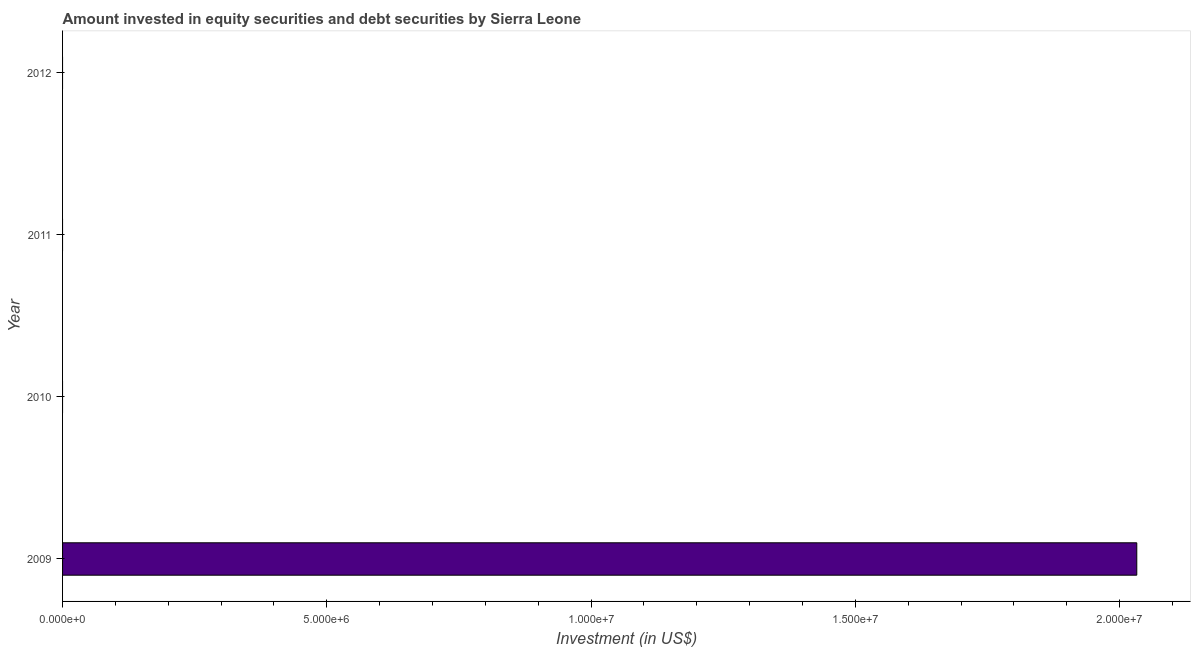Does the graph contain grids?
Offer a terse response. No. What is the title of the graph?
Give a very brief answer. Amount invested in equity securities and debt securities by Sierra Leone. What is the label or title of the X-axis?
Your answer should be compact. Investment (in US$). Across all years, what is the maximum portfolio investment?
Provide a short and direct response. 2.03e+07. What is the sum of the portfolio investment?
Your response must be concise. 2.03e+07. What is the average portfolio investment per year?
Offer a terse response. 5.08e+06. In how many years, is the portfolio investment greater than 1000000 US$?
Make the answer very short. 1. What is the difference between the highest and the lowest portfolio investment?
Ensure brevity in your answer.  2.03e+07. In how many years, is the portfolio investment greater than the average portfolio investment taken over all years?
Ensure brevity in your answer.  1. How many years are there in the graph?
Your answer should be very brief. 4. What is the difference between two consecutive major ticks on the X-axis?
Ensure brevity in your answer.  5.00e+06. Are the values on the major ticks of X-axis written in scientific E-notation?
Provide a short and direct response. Yes. What is the Investment (in US$) in 2009?
Keep it short and to the point. 2.03e+07. What is the Investment (in US$) in 2010?
Your answer should be very brief. 0. 